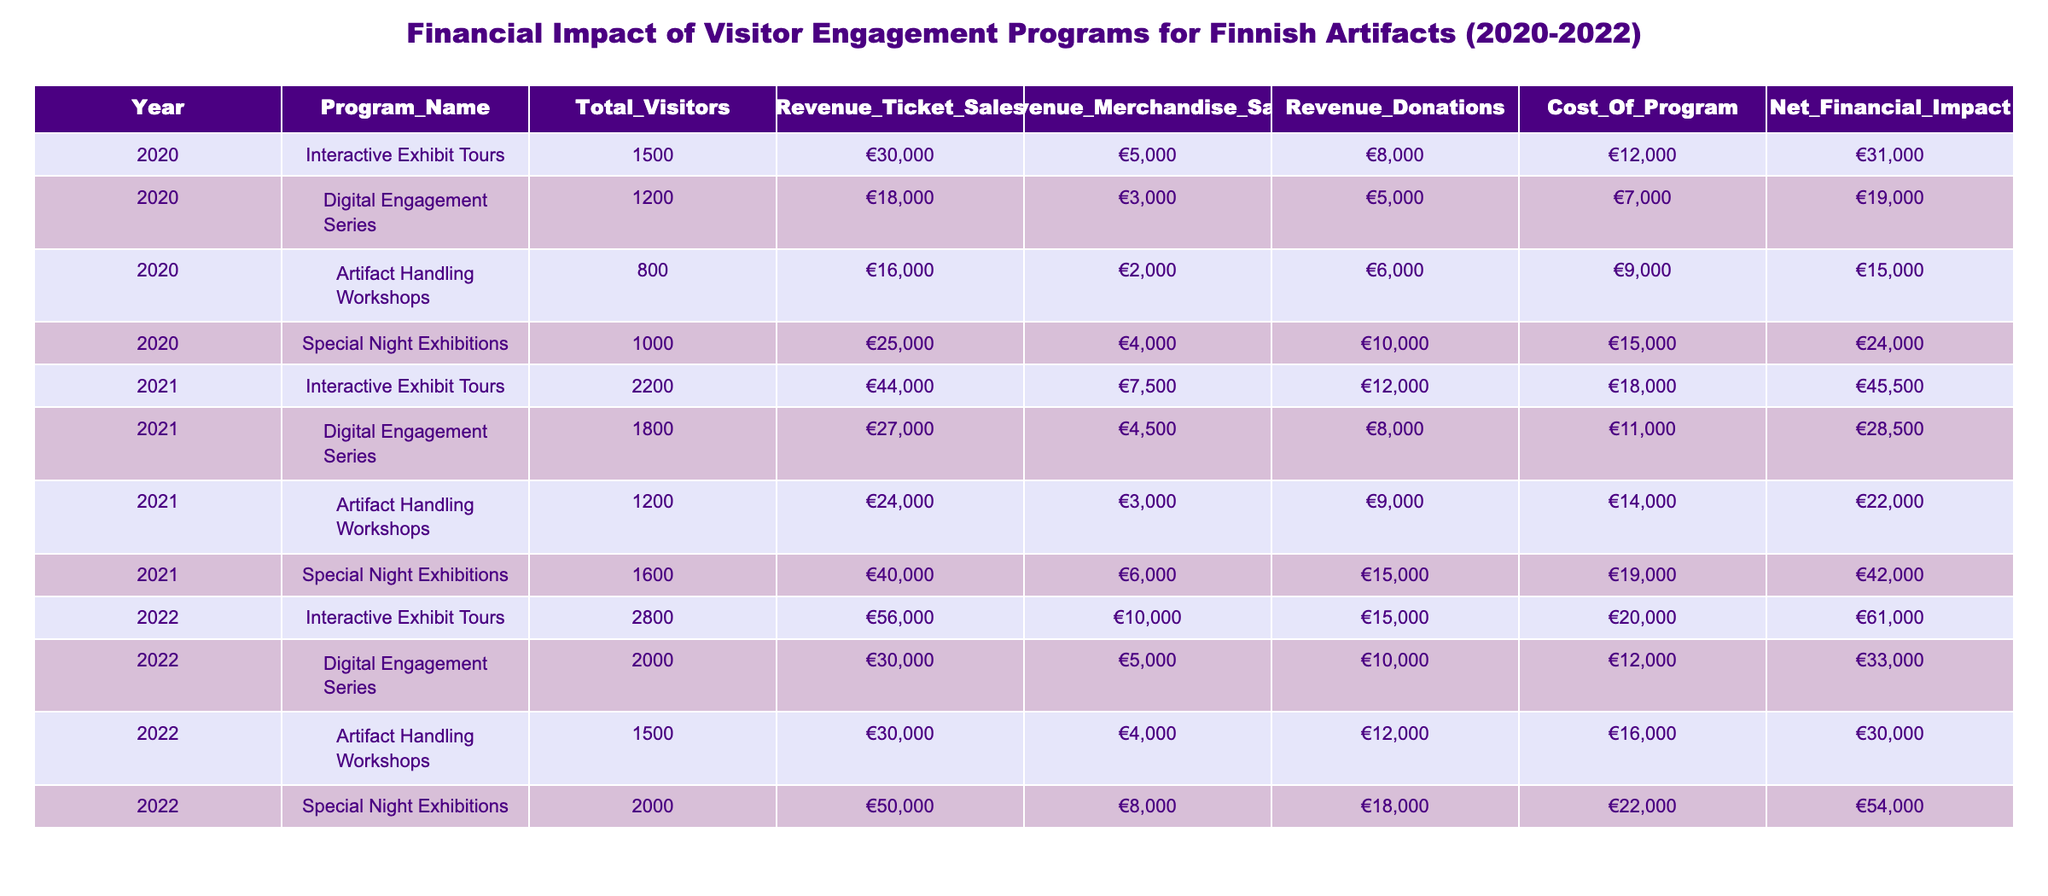What was the total revenue from ticket sales in 2021? In 2021, the revenue from ticket sales for each program can be summed up: Interactive Exhibit Tours (€44,000) + Digital Engagement Series (€27,000) + Artifact Handling Workshops (€24,000) + Special Night Exhibitions (€40,000) = €135,000.
Answer: €135,000 Which program had the highest net financial impact in 2022? By comparing the net financial impacts for all programs in 2022, we find: Interactive Exhibit Tours (€61,000), Digital Engagement Series (€33,000), Artifact Handling Workshops (€30,000), and Special Night Exhibitions (€54,000). The highest is €61,000 from Interactive Exhibit Tours.
Answer: Interactive Exhibit Tours Did the revenue from merchandise sales increase from 2020 to 2021 for all programs? By examining the merchandise sales for each program, the comparisons are as follows: Interactive Exhibit Tours (€5,000 to €7,500), Digital Engagement Series (€3,000 to €4,500), Artifact Handling Workshops (€2,000 to €3,000), Special Night Exhibitions (€4,000 to €6,000). All except for Artifact Handling Workshops increased.
Answer: No What is the average net financial impact of all programs in 2020? First, we need to sum the net financial impacts for 2020: €31,000 (Interactive Exhibit Tours) + €19,000 (Digital Engagement Series) + €15,000 (Artifact Handling Workshops) + €24,000 (Special Night Exhibitions) = €89,000. Then, we divide by the number of programs (4) to get the average: €89,000 / 4 = €22,250.
Answer: €22,250 What was the overall percentage increase in total visitors from 2020 to 2022? Total visitors in 2020: 1500 + 1200 + 800 + 1000 = 3500. Total visitors in 2022: 2800 + 2000 + 1500 + 2000 = 8200. The increase is (8200 - 3500) = 4700. To find the percentage increase, we calculate (4700 / 3500) * 100 ≈ 134.29%.
Answer: Approximately 134.29% 